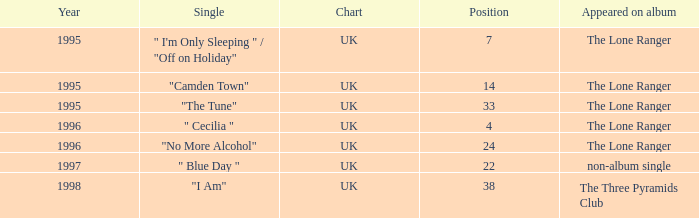When the position is less than 7, what is the appeared on album? The Lone Ranger. 